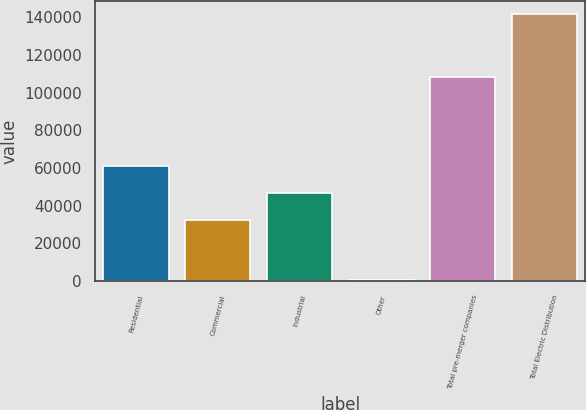<chart> <loc_0><loc_0><loc_500><loc_500><bar_chart><fcel>Residential<fcel>Commercial<fcel>Industrial<fcel>Other<fcel>Total pre-merger companies<fcel>Total Electric Distribution<nl><fcel>60823<fcel>32610<fcel>46716.5<fcel>513<fcel>108129<fcel>141578<nl></chart> 